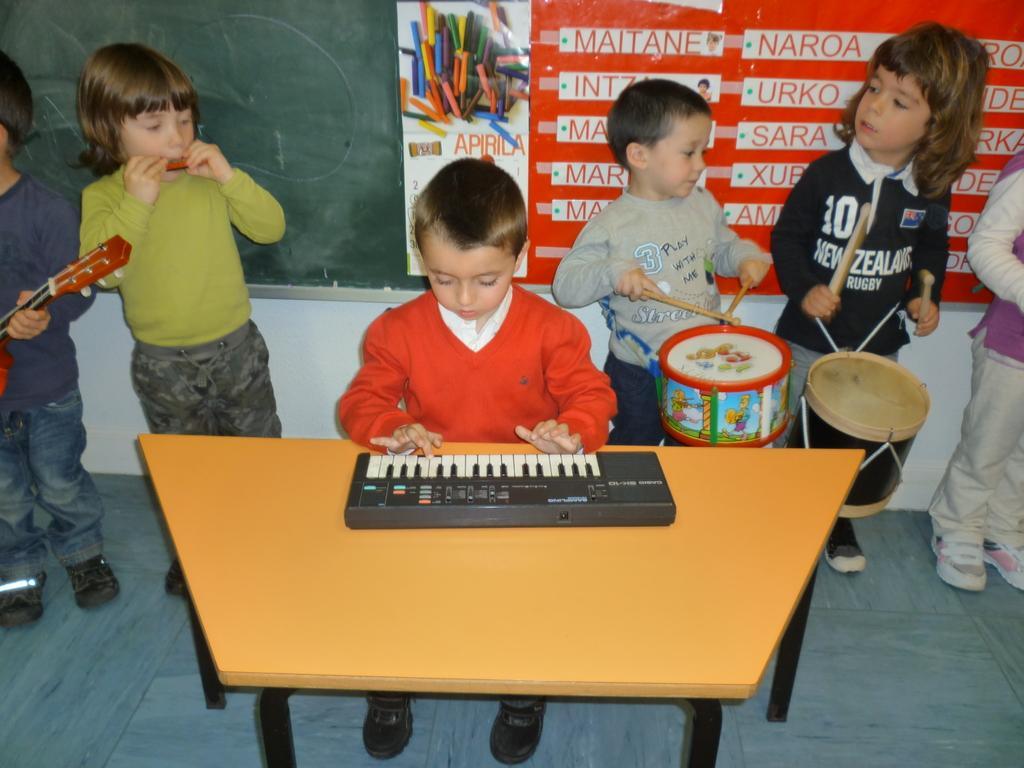How would you summarize this image in a sentence or two? in there are many children a one child is sitting on a chair and playing a piano which is in front of him on the table. 